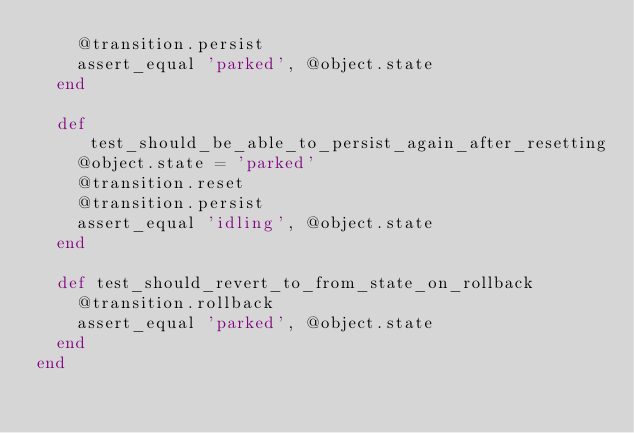<code> <loc_0><loc_0><loc_500><loc_500><_Ruby_>    @transition.persist
    assert_equal 'parked', @object.state
  end

  def test_should_be_able_to_persist_again_after_resetting
    @object.state = 'parked'
    @transition.reset
    @transition.persist
    assert_equal 'idling', @object.state
  end

  def test_should_revert_to_from_state_on_rollback
    @transition.rollback
    assert_equal 'parked', @object.state
  end
end
</code> 